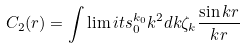<formula> <loc_0><loc_0><loc_500><loc_500>C _ { 2 } ( r ) = \int \lim i t s _ { 0 } ^ { k _ { 0 } } k ^ { 2 } d k \zeta _ { k } \frac { \sin k r } { k r }</formula> 